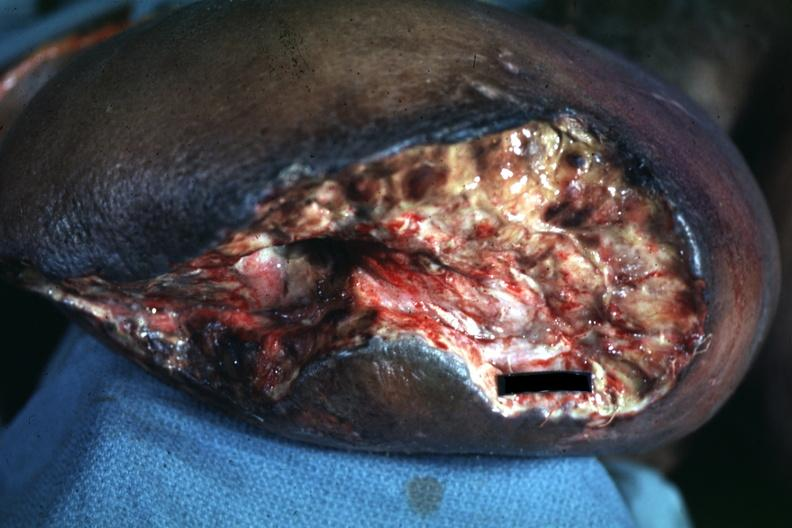what appears to be mid thigh?
Answer the question using a single word or phrase. Wound 